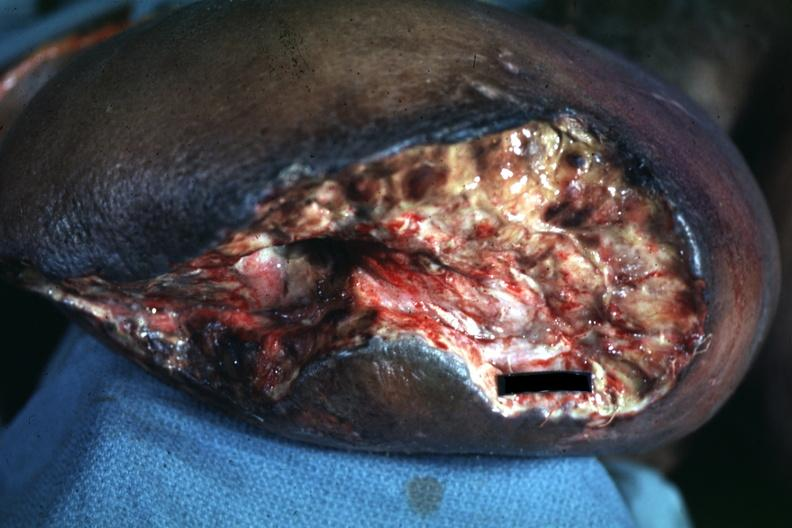what appears to be mid thigh?
Answer the question using a single word or phrase. Wound 